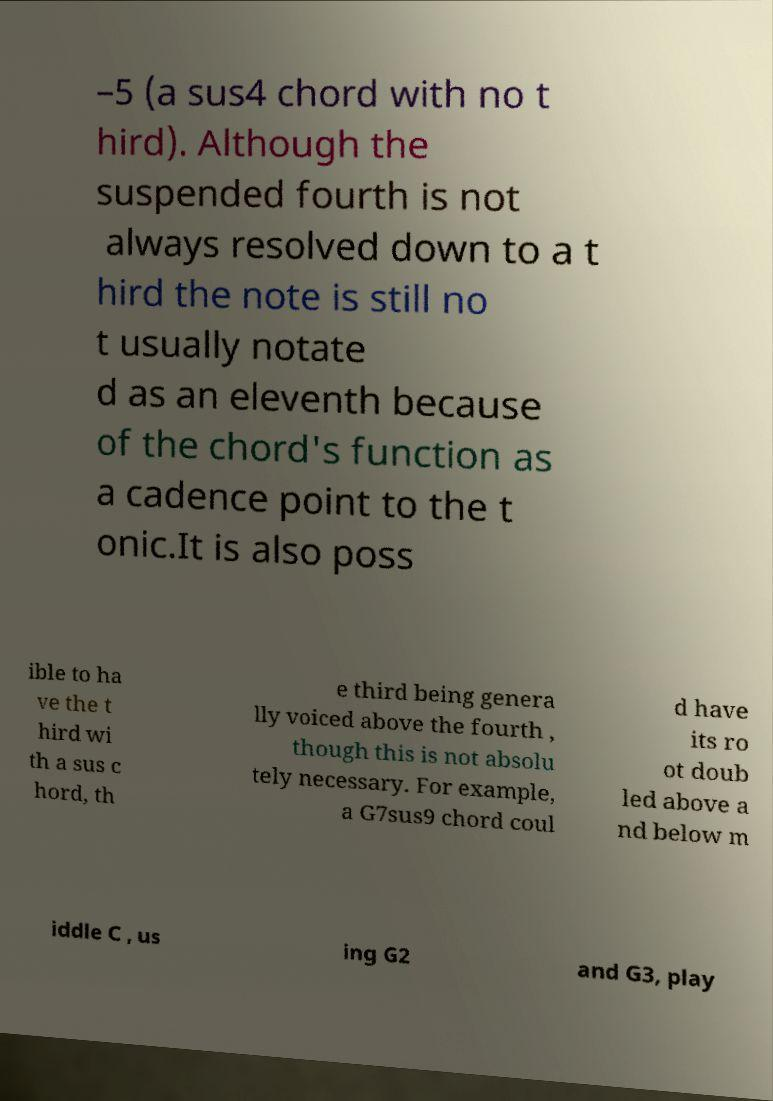For documentation purposes, I need the text within this image transcribed. Could you provide that? –5 (a sus4 chord with no t hird). Although the suspended fourth is not always resolved down to a t hird the note is still no t usually notate d as an eleventh because of the chord's function as a cadence point to the t onic.It is also poss ible to ha ve the t hird wi th a sus c hord, th e third being genera lly voiced above the fourth , though this is not absolu tely necessary. For example, a G7sus9 chord coul d have its ro ot doub led above a nd below m iddle C , us ing G2 and G3, play 